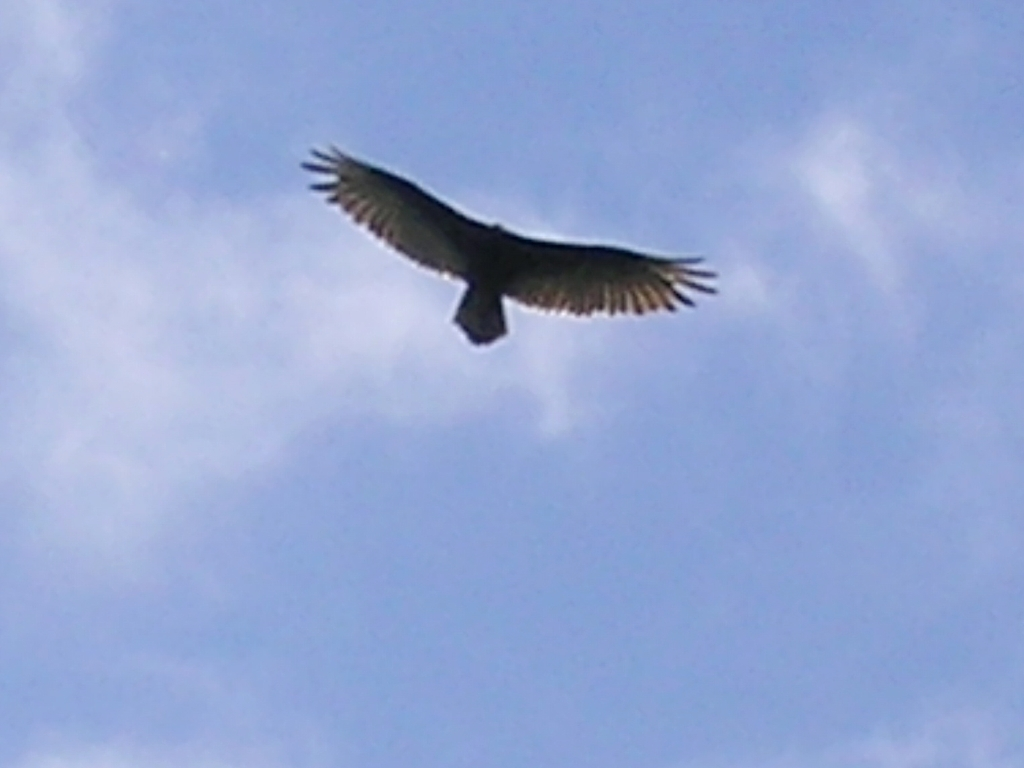What emotions does this image evoke? The image of a bird in flight against the backdrop of an expansive sky can evoke a sense of freedom and tranquility. It might also inspire awe or admiration for the natural world and the graceful and seemingly effortless way birds navigate the sky. For some, it may also stir a feeling of wanderlust or the desire to explore and be as free as the bird depicted here. 